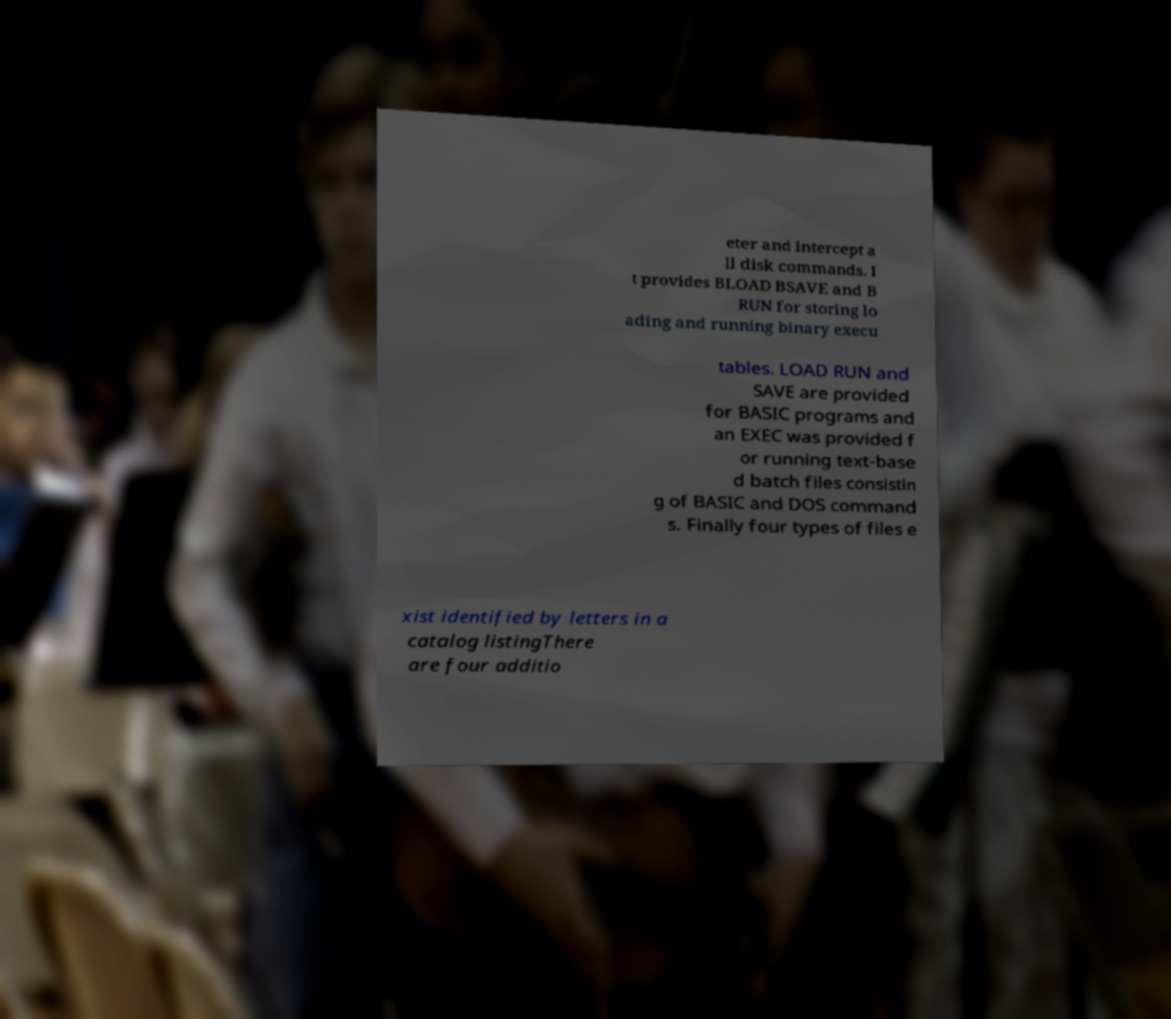Can you accurately transcribe the text from the provided image for me? eter and intercept a ll disk commands. I t provides BLOAD BSAVE and B RUN for storing lo ading and running binary execu tables. LOAD RUN and SAVE are provided for BASIC programs and an EXEC was provided f or running text-base d batch files consistin g of BASIC and DOS command s. Finally four types of files e xist identified by letters in a catalog listingThere are four additio 